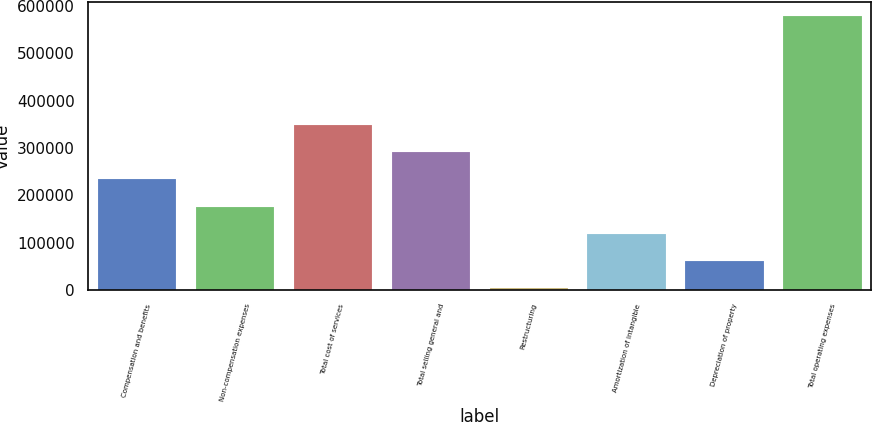Convert chart. <chart><loc_0><loc_0><loc_500><loc_500><bar_chart><fcel>Compensation and benefits<fcel>Non-compensation expenses<fcel>Total cost of services<fcel>Total selling general and<fcel>Restructuring<fcel>Amortization of intangible<fcel>Depreciation of property<fcel>Total operating expenses<nl><fcel>233734<fcel>176199<fcel>348803<fcel>291268<fcel>3594<fcel>118664<fcel>61128.9<fcel>578943<nl></chart> 